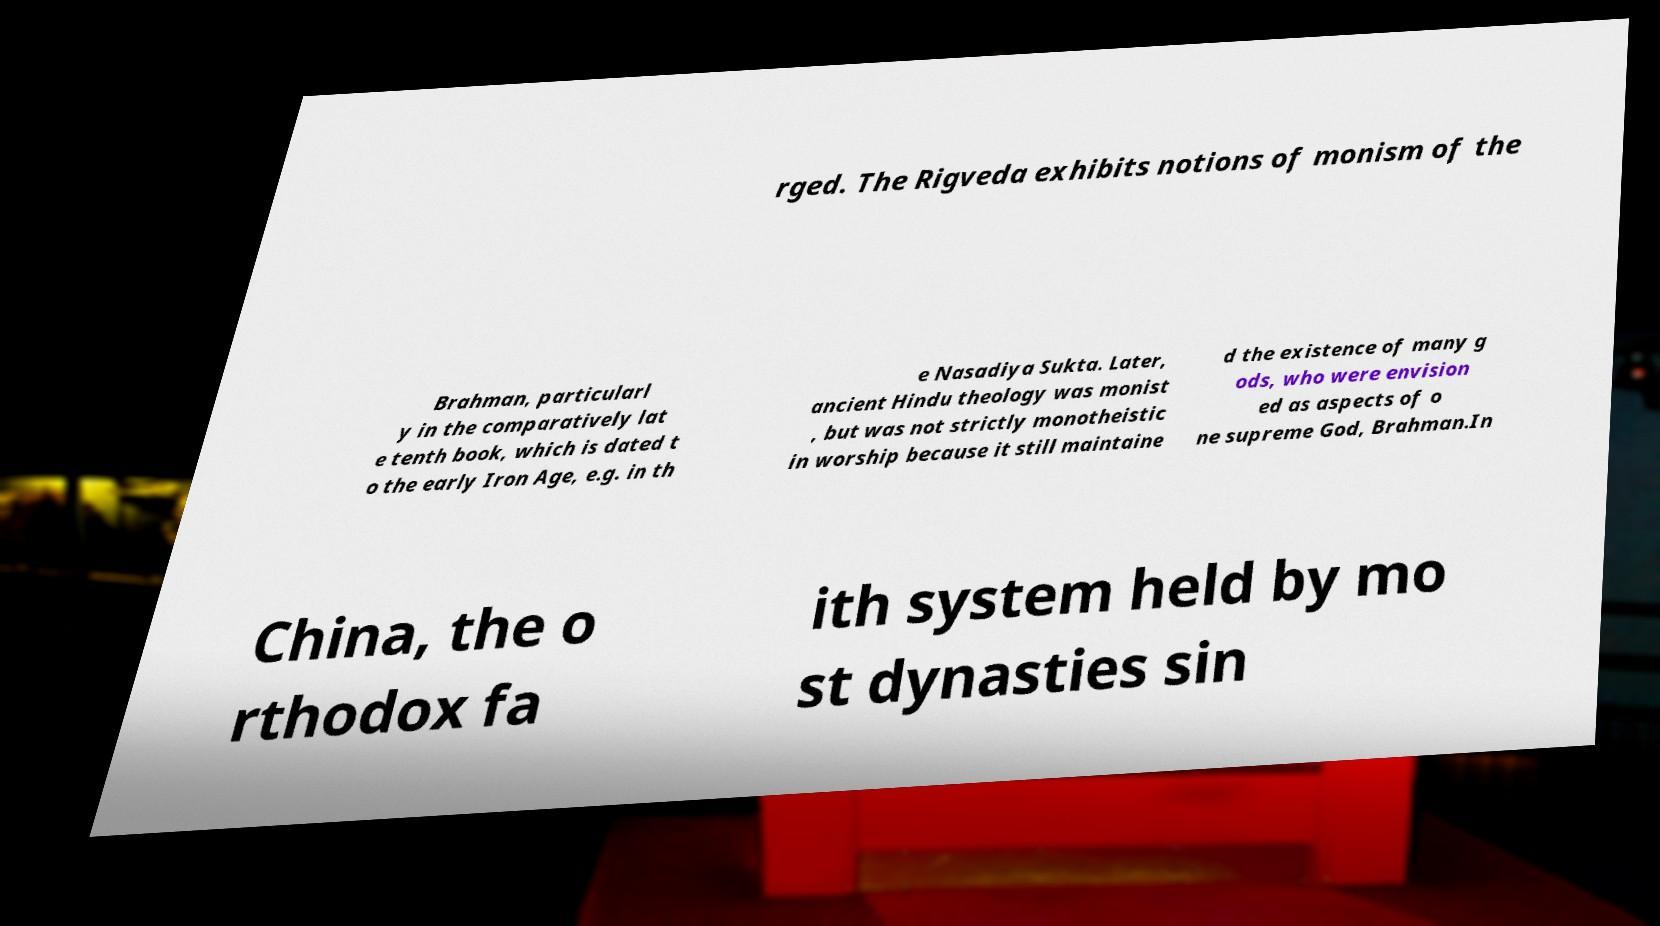Can you read and provide the text displayed in the image?This photo seems to have some interesting text. Can you extract and type it out for me? rged. The Rigveda exhibits notions of monism of the Brahman, particularl y in the comparatively lat e tenth book, which is dated t o the early Iron Age, e.g. in th e Nasadiya Sukta. Later, ancient Hindu theology was monist , but was not strictly monotheistic in worship because it still maintaine d the existence of many g ods, who were envision ed as aspects of o ne supreme God, Brahman.In China, the o rthodox fa ith system held by mo st dynasties sin 